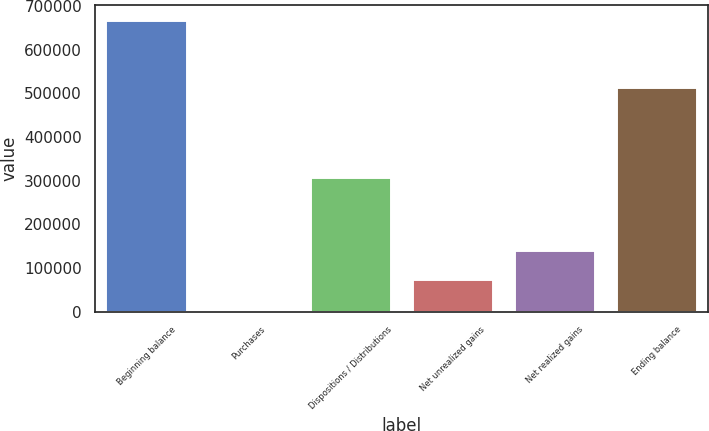Convert chart. <chart><loc_0><loc_0><loc_500><loc_500><bar_chart><fcel>Beginning balance<fcel>Purchases<fcel>Dispositions / Distributions<fcel>Net unrealized gains<fcel>Net realized gains<fcel>Ending balance<nl><fcel>667710<fcel>3392<fcel>307268<fcel>73802<fcel>140234<fcel>513973<nl></chart> 